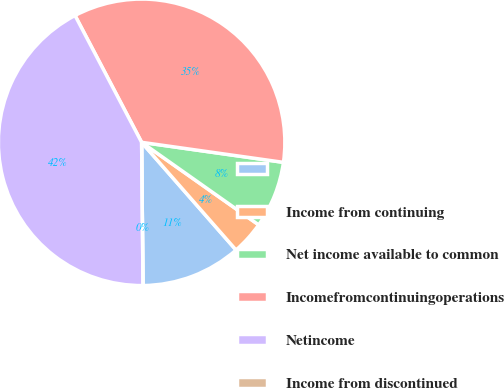Convert chart to OTSL. <chart><loc_0><loc_0><loc_500><loc_500><pie_chart><ecel><fcel>Income from continuing<fcel>Net income available to common<fcel>Incomefromcontinuingoperations<fcel>Netincome<fcel>Income from discontinued<nl><fcel>11.3%<fcel>3.77%<fcel>7.54%<fcel>34.93%<fcel>42.46%<fcel>0.0%<nl></chart> 